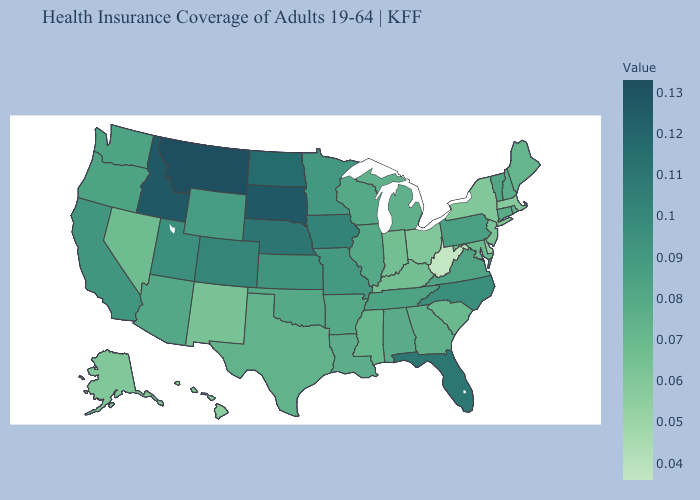Among the states that border Iowa , does Missouri have the highest value?
Quick response, please. No. Does Montana have the highest value in the USA?
Concise answer only. Yes. Among the states that border Vermont , does Massachusetts have the lowest value?
Be succinct. Yes. Does New York have the highest value in the Northeast?
Write a very short answer. No. Does Montana have the highest value in the USA?
Be succinct. Yes. Is the legend a continuous bar?
Be succinct. Yes. Does North Carolina have the highest value in the South?
Keep it brief. No. 